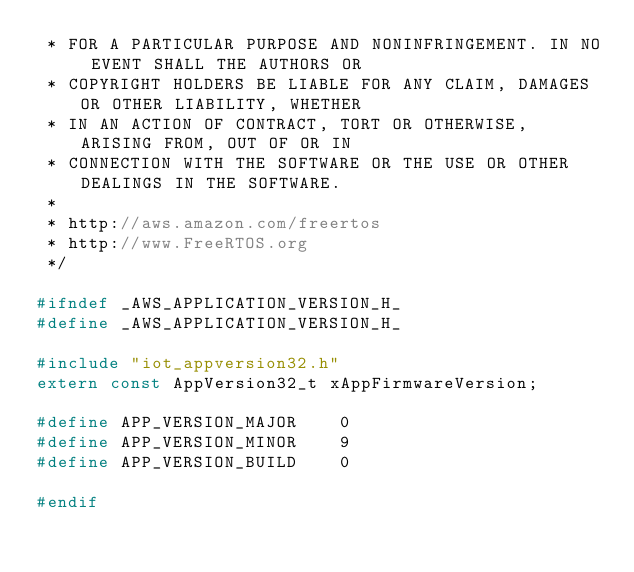Convert code to text. <code><loc_0><loc_0><loc_500><loc_500><_C_> * FOR A PARTICULAR PURPOSE AND NONINFRINGEMENT. IN NO EVENT SHALL THE AUTHORS OR
 * COPYRIGHT HOLDERS BE LIABLE FOR ANY CLAIM, DAMAGES OR OTHER LIABILITY, WHETHER
 * IN AN ACTION OF CONTRACT, TORT OR OTHERWISE, ARISING FROM, OUT OF OR IN
 * CONNECTION WITH THE SOFTWARE OR THE USE OR OTHER DEALINGS IN THE SOFTWARE.
 *
 * http://aws.amazon.com/freertos
 * http://www.FreeRTOS.org
 */

#ifndef _AWS_APPLICATION_VERSION_H_
#define _AWS_APPLICATION_VERSION_H_

#include "iot_appversion32.h"
extern const AppVersion32_t xAppFirmwareVersion;

#define APP_VERSION_MAJOR    0
#define APP_VERSION_MINOR    9
#define APP_VERSION_BUILD    0

#endif
</code> 